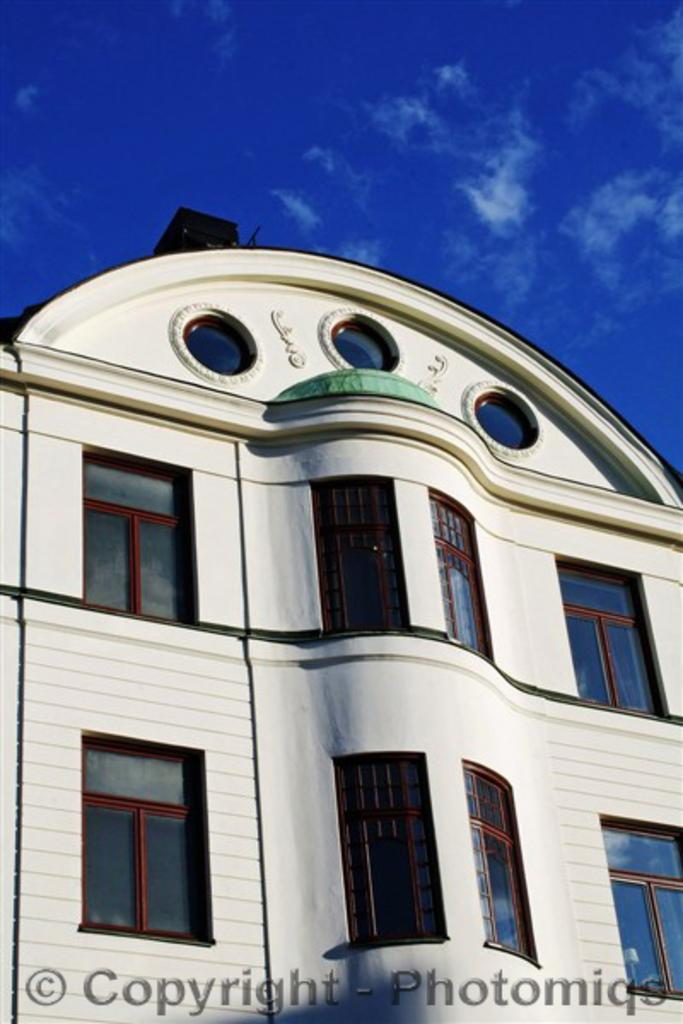What is the main subject of the image? There is a building at the center of the image. What can be seen in the background of the image? There is a sky visible in the background of the image. What type of comb is being used to form the shape of the truck in the image? There is no comb, form, or truck present in the image. 